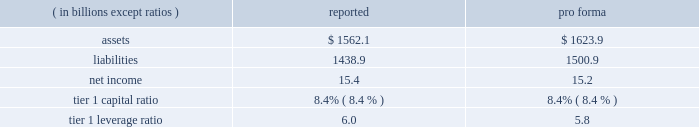Notes to consolidated financial statements jpmorgan chase & co .
150 jpmorgan chase & co .
/ 2007 annual report expected loss modeling in 2006 , the firm restructured four multi-seller conduits that it administers .
The restructurings included enhancing the firm 2019s expected loss model .
In determining the primary beneficiary of the conduits it administers , the firm uses a monte carlo 2013based model to estimate the expected losses of each of the conduits and considers the rela- tive rights and obligations of each of the variable interest holders .
The variability to be considered in the modeling of expected losses is based on the design of the entity .
The firm 2019s traditional multi-seller conduits are designed to pass credit risk , not liquidity risk , to its vari- able interest holders , as the assets are intended to be held in the conduit for the longer term .
Under fin 46r , the firm is required to run the monte carlo-based expected loss model each time a reconsideration event occurs .
In applying this guidance to the conduits , the following events are considered to be reconsideration events as they could affect the determination of the primary beneficiary of the conduits : 2022 new deals , including the issuance of new or additional variable interests ( credit support , liquidity facilities , etc ) ; 2022 changes in usage , including the change in the level of outstand- ing variable interests ( credit support , liquidity facilities , etc ) ; 2022 modifications of asset purchase agreements ; and 2022 sales of interests held by the primary beneficiary .
From an operational perspective , the firm does not run its monte carlo-based expected loss model every time there is a reconsidera- tion event due to the frequency of their occurrence .
Instead , the firm runs its expected loss model each quarter and includes a growth assumption for each conduit to ensure that a sufficient amount of elns exists for each conduit at any point during the quarter .
As part of its normal quarterly model review , the firm reassesses the underlying assumptions and inputs of the expected loss model .
During the second half of 2007 , certain assumptions used in the model were adjusted to reflect the then current market conditions .
Specifically , risk ratings and loss given default assumptions relating to residential subprime mortgage exposures were modified .
For other nonmortgage-related asset classes , the firm determined that the assumptions in the model required little adjustment .
As a result of the updates to the model , during the fourth quarter of 2007 the terms of the elns were renegotiated to increase the level of commit- ment and funded amounts to be provided by the eln holders .
The total amount of expected loss notes outstanding at december 31 , 2007 and 2006 , were $ 130 million and $ 54 million , respectively .
Management concluded that the model assumptions used were reflective of market participant 2019s assumptions and appropriately considered the probability of a recurrence of recent market events .
Qualitative considerations the multi-seller conduits are primarily designed to provide an efficient means for clients to access the commercial paper market .
The firm believes the conduits effectively disperse risk among all parties and that the preponderance of economic risk in the firm 2019s multi-seller conduits is not held by jpmorgan chase .
The percentage of assets in the multi-seller conduits that the firm views as client-related represent 99% ( 99 % ) and 98% ( 98 % ) of the total conduits 2019 holdings at december 31 , 2007 and 2006 , respectively .
Consolidated sensitivity analysis on capital it is possible that the firm could be required to consolidate a vie if it were determined that the firm became the primary beneficiary of the vie under the provisions of fin 46r .
The factors involved in making the determination of whether or not a vie should be consolidated are dis- cussed above and in note 1 on page 108 of this annual report .
The table below shows the impact on the firm 2019s reported assets , liabilities , net income , tier 1 capital ratio and tier 1 leverage ratio if the firm were required to consolidate all of the multi-seller conduits that it administers .
As of or for the year ending december 31 , 2007 .
The firm could fund purchases of assets from vies should it become necessary .
Investor intermediation as a financial intermediary , the firm creates certain types of vies and also structures transactions , typically derivative structures , with these vies to meet investor needs .
The firm may also provide liquidity and other support .
The risks inherent in the derivative instruments or liq- uidity commitments are managed similarly to other credit , market or liquidity risks to which the firm is exposed .
The principal types of vies for which the firm is engaged in these structuring activities are municipal bond vehicles , credit-linked note vehicles and collateralized debt obligation vehicles .
Municipal bond vehicles the firm has created a series of secondary market trusts that provide short-term investors with qualifying tax-exempt investments , and that allow investors in tax-exempt securities to finance their investments at short-term tax-exempt rates .
In a typical transaction , the vehicle pur- chases fixed-rate longer-term highly rated municipal bonds and funds the purchase by issuing two types of securities : ( 1 ) putable floating- rate certificates and ( 2 ) inverse floating-rate residual interests ( 201cresid- ual interests 201d ) .
The maturity of each of the putable floating-rate certifi- cates and the residual interests is equal to the life of the vehicle , while the maturity of the underlying municipal bonds is longer .
Holders of the putable floating-rate certificates may 201cput 201d , or tender , the certifi- cates if the remarketing agent cannot successfully remarket the float- ing-rate certificates to another investor .
A liquidity facility conditionally obligates the liquidity provider to fund the purchase of the tendered floating-rate certificates .
Upon termination of the vehicle , if the pro- ceeds from the sale of the underlying municipal bonds are not suffi- cient to repay the liquidity facility , the liquidity provider has recourse either to excess collateralization in the vehicle or the residual interest holders for reimbursement .
The third-party holders of the residual interests in these vehicles could experience losses if the face amount of the putable floating-rate cer- tificates exceeds the market value of the municipal bonds upon termi- nation of the vehicle .
Certain vehicles require a smaller initial invest- ment by the residual interest holders and thus do not result in excess collateralization .
For these vehicles there exists a reimbursement obli- .
What is the average assets ( in billions ) for each of the firm's self sponsored conduits? 
Computations: (1562.1 / 4)
Answer: 390.525. Notes to consolidated financial statements jpmorgan chase & co .
150 jpmorgan chase & co .
/ 2007 annual report expected loss modeling in 2006 , the firm restructured four multi-seller conduits that it administers .
The restructurings included enhancing the firm 2019s expected loss model .
In determining the primary beneficiary of the conduits it administers , the firm uses a monte carlo 2013based model to estimate the expected losses of each of the conduits and considers the rela- tive rights and obligations of each of the variable interest holders .
The variability to be considered in the modeling of expected losses is based on the design of the entity .
The firm 2019s traditional multi-seller conduits are designed to pass credit risk , not liquidity risk , to its vari- able interest holders , as the assets are intended to be held in the conduit for the longer term .
Under fin 46r , the firm is required to run the monte carlo-based expected loss model each time a reconsideration event occurs .
In applying this guidance to the conduits , the following events are considered to be reconsideration events as they could affect the determination of the primary beneficiary of the conduits : 2022 new deals , including the issuance of new or additional variable interests ( credit support , liquidity facilities , etc ) ; 2022 changes in usage , including the change in the level of outstand- ing variable interests ( credit support , liquidity facilities , etc ) ; 2022 modifications of asset purchase agreements ; and 2022 sales of interests held by the primary beneficiary .
From an operational perspective , the firm does not run its monte carlo-based expected loss model every time there is a reconsidera- tion event due to the frequency of their occurrence .
Instead , the firm runs its expected loss model each quarter and includes a growth assumption for each conduit to ensure that a sufficient amount of elns exists for each conduit at any point during the quarter .
As part of its normal quarterly model review , the firm reassesses the underlying assumptions and inputs of the expected loss model .
During the second half of 2007 , certain assumptions used in the model were adjusted to reflect the then current market conditions .
Specifically , risk ratings and loss given default assumptions relating to residential subprime mortgage exposures were modified .
For other nonmortgage-related asset classes , the firm determined that the assumptions in the model required little adjustment .
As a result of the updates to the model , during the fourth quarter of 2007 the terms of the elns were renegotiated to increase the level of commit- ment and funded amounts to be provided by the eln holders .
The total amount of expected loss notes outstanding at december 31 , 2007 and 2006 , were $ 130 million and $ 54 million , respectively .
Management concluded that the model assumptions used were reflective of market participant 2019s assumptions and appropriately considered the probability of a recurrence of recent market events .
Qualitative considerations the multi-seller conduits are primarily designed to provide an efficient means for clients to access the commercial paper market .
The firm believes the conduits effectively disperse risk among all parties and that the preponderance of economic risk in the firm 2019s multi-seller conduits is not held by jpmorgan chase .
The percentage of assets in the multi-seller conduits that the firm views as client-related represent 99% ( 99 % ) and 98% ( 98 % ) of the total conduits 2019 holdings at december 31 , 2007 and 2006 , respectively .
Consolidated sensitivity analysis on capital it is possible that the firm could be required to consolidate a vie if it were determined that the firm became the primary beneficiary of the vie under the provisions of fin 46r .
The factors involved in making the determination of whether or not a vie should be consolidated are dis- cussed above and in note 1 on page 108 of this annual report .
The table below shows the impact on the firm 2019s reported assets , liabilities , net income , tier 1 capital ratio and tier 1 leverage ratio if the firm were required to consolidate all of the multi-seller conduits that it administers .
As of or for the year ending december 31 , 2007 .
The firm could fund purchases of assets from vies should it become necessary .
Investor intermediation as a financial intermediary , the firm creates certain types of vies and also structures transactions , typically derivative structures , with these vies to meet investor needs .
The firm may also provide liquidity and other support .
The risks inherent in the derivative instruments or liq- uidity commitments are managed similarly to other credit , market or liquidity risks to which the firm is exposed .
The principal types of vies for which the firm is engaged in these structuring activities are municipal bond vehicles , credit-linked note vehicles and collateralized debt obligation vehicles .
Municipal bond vehicles the firm has created a series of secondary market trusts that provide short-term investors with qualifying tax-exempt investments , and that allow investors in tax-exempt securities to finance their investments at short-term tax-exempt rates .
In a typical transaction , the vehicle pur- chases fixed-rate longer-term highly rated municipal bonds and funds the purchase by issuing two types of securities : ( 1 ) putable floating- rate certificates and ( 2 ) inverse floating-rate residual interests ( 201cresid- ual interests 201d ) .
The maturity of each of the putable floating-rate certifi- cates and the residual interests is equal to the life of the vehicle , while the maturity of the underlying municipal bonds is longer .
Holders of the putable floating-rate certificates may 201cput 201d , or tender , the certifi- cates if the remarketing agent cannot successfully remarket the float- ing-rate certificates to another investor .
A liquidity facility conditionally obligates the liquidity provider to fund the purchase of the tendered floating-rate certificates .
Upon termination of the vehicle , if the pro- ceeds from the sale of the underlying municipal bonds are not suffi- cient to repay the liquidity facility , the liquidity provider has recourse either to excess collateralization in the vehicle or the residual interest holders for reimbursement .
The third-party holders of the residual interests in these vehicles could experience losses if the face amount of the putable floating-rate cer- tificates exceeds the market value of the municipal bonds upon termi- nation of the vehicle .
Certain vehicles require a smaller initial invest- ment by the residual interest holders and thus do not result in excess collateralization .
For these vehicles there exists a reimbursement obli- .
In billions , what is the pro-forma shareholders equity? 
Rationale: assets minus liabilities= se
Computations: (1623.9 - 1500.9)
Answer: 123.0. 